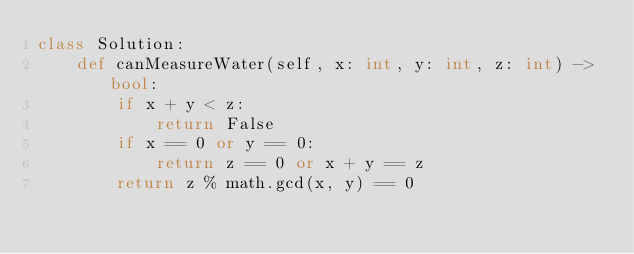<code> <loc_0><loc_0><loc_500><loc_500><_Python_>class Solution:
    def canMeasureWater(self, x: int, y: int, z: int) -> bool:
        if x + y < z:
            return False
        if x == 0 or y == 0:
            return z == 0 or x + y == z
        return z % math.gcd(x, y) == 0
</code> 